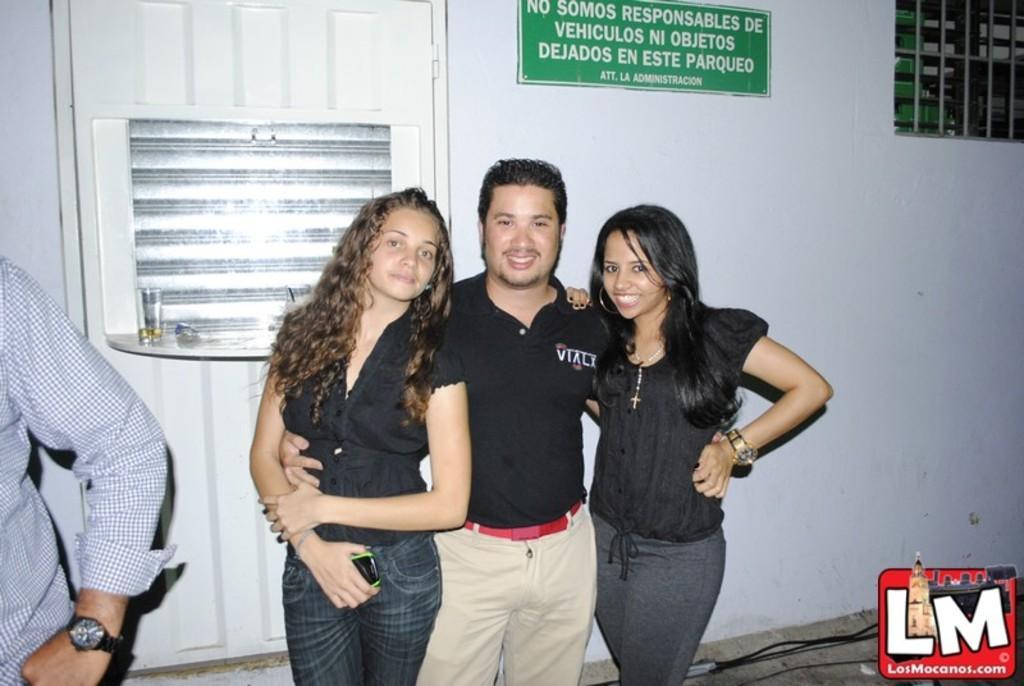Please provide a concise description of this image. In this image, we can see three persons are watching and smiling. They are standing side by side. Here a man is holding two women. On the left side of the image, we can see a person's hand. Background there is a wall, door, board, grille, rack and few objects. On the right side bottom, we can see wires and logo. 